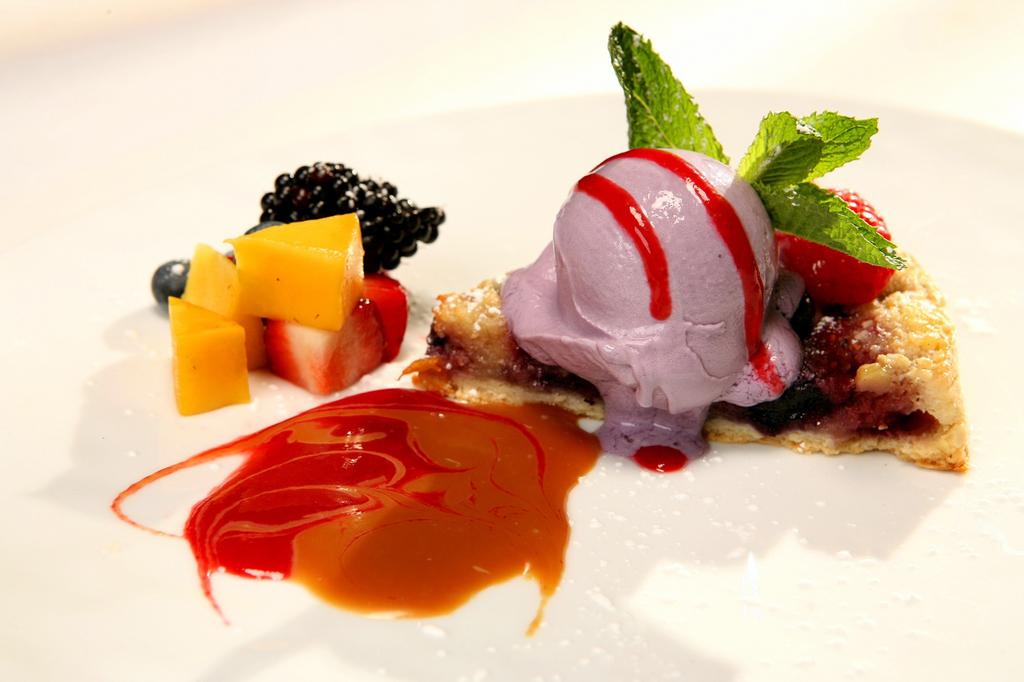What type of dessert is present in the image? There is ice cream in the image. What other food items can be seen in the image? There are fruits in the image. What scientific discovery was made while examining the ice cream in the image? There is no scientific discovery mentioned or implied in the image; it simply shows ice cream and fruits. 